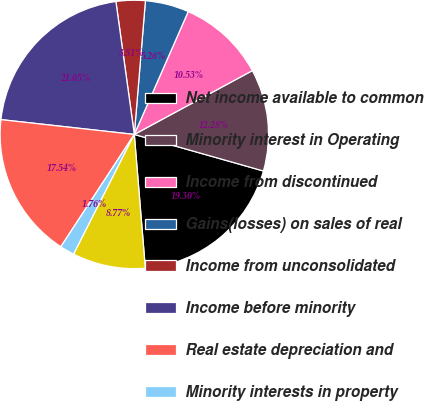Convert chart to OTSL. <chart><loc_0><loc_0><loc_500><loc_500><pie_chart><fcel>Net income available to common<fcel>Minority interest in Operating<fcel>Income from discontinued<fcel>Gains(losses) on sales of real<fcel>Income from unconsolidated<fcel>Income before minority<fcel>Real estate depreciation and<fcel>Minority interests in property<fcel>Preferred dividends and<nl><fcel>19.3%<fcel>12.28%<fcel>10.53%<fcel>5.26%<fcel>3.51%<fcel>21.05%<fcel>17.54%<fcel>1.76%<fcel>8.77%<nl></chart> 